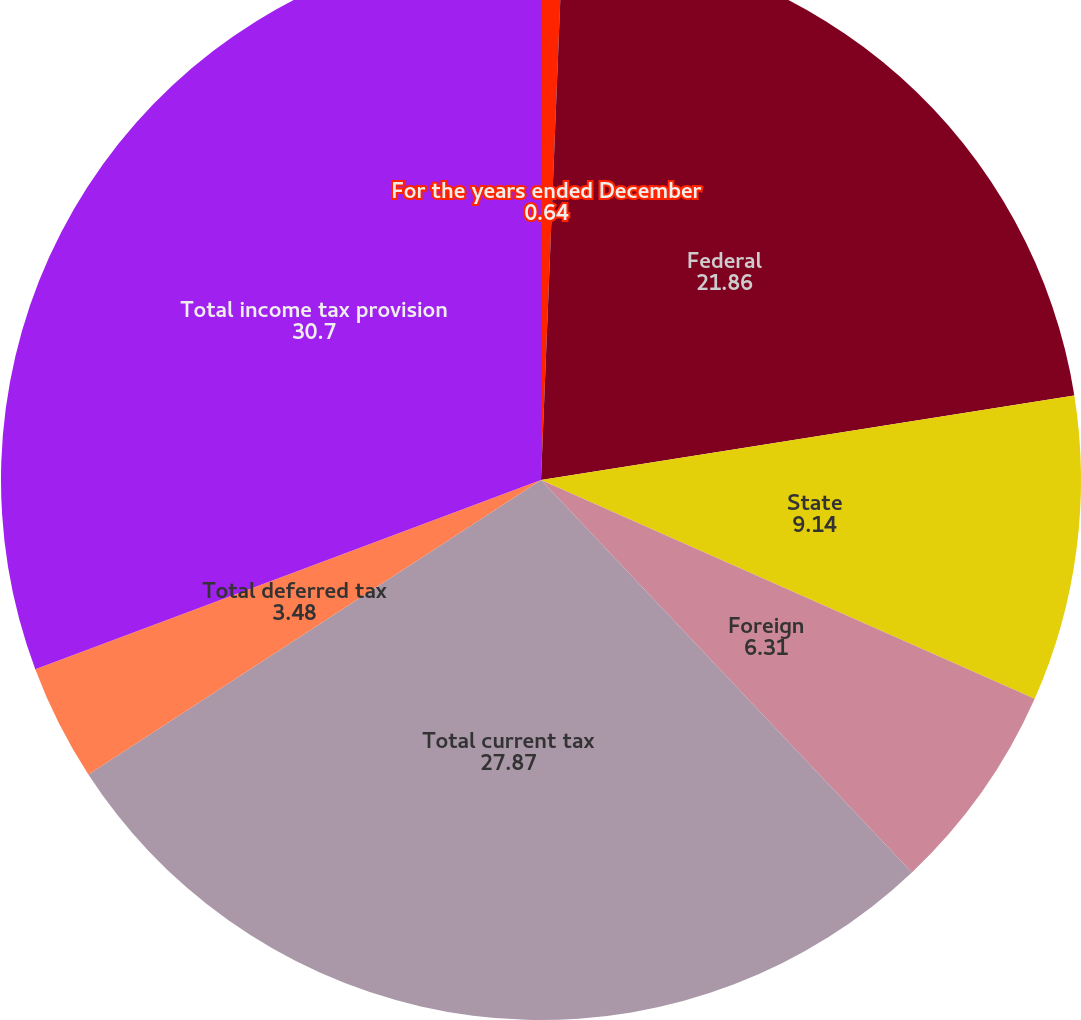<chart> <loc_0><loc_0><loc_500><loc_500><pie_chart><fcel>For the years ended December<fcel>Federal<fcel>State<fcel>Foreign<fcel>Total current tax<fcel>Total deferred tax<fcel>Total income tax provision<nl><fcel>0.64%<fcel>21.86%<fcel>9.14%<fcel>6.31%<fcel>27.87%<fcel>3.48%<fcel>30.7%<nl></chart> 